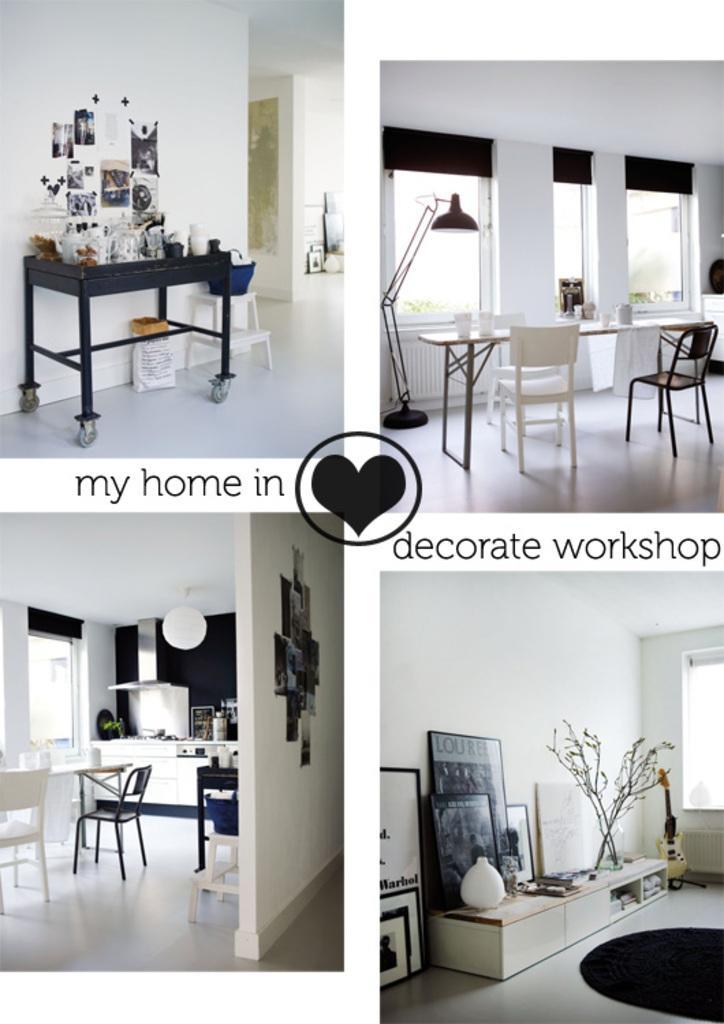Could you give a brief overview of what you see in this image? In this image, there are four different images. On the right there are chairs, tables, windows, lamp. On the right bottom there are photo frames, guitar, window, plant and a wall. On the left bottom there are chairs, table, lamp, window, tables. On the left top, there is a table on that there are many objects and there are posters. 